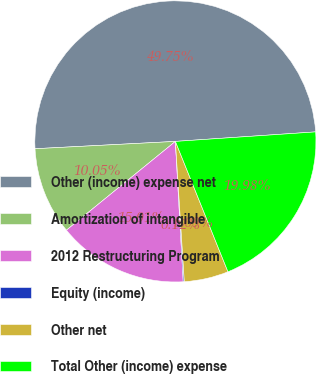Convert chart. <chart><loc_0><loc_0><loc_500><loc_500><pie_chart><fcel>Other (income) expense net<fcel>Amortization of intangible<fcel>2012 Restructuring Program<fcel>Equity (income)<fcel>Other net<fcel>Total Other (income) expense<nl><fcel>49.75%<fcel>10.05%<fcel>15.01%<fcel>0.12%<fcel>5.09%<fcel>19.98%<nl></chart> 